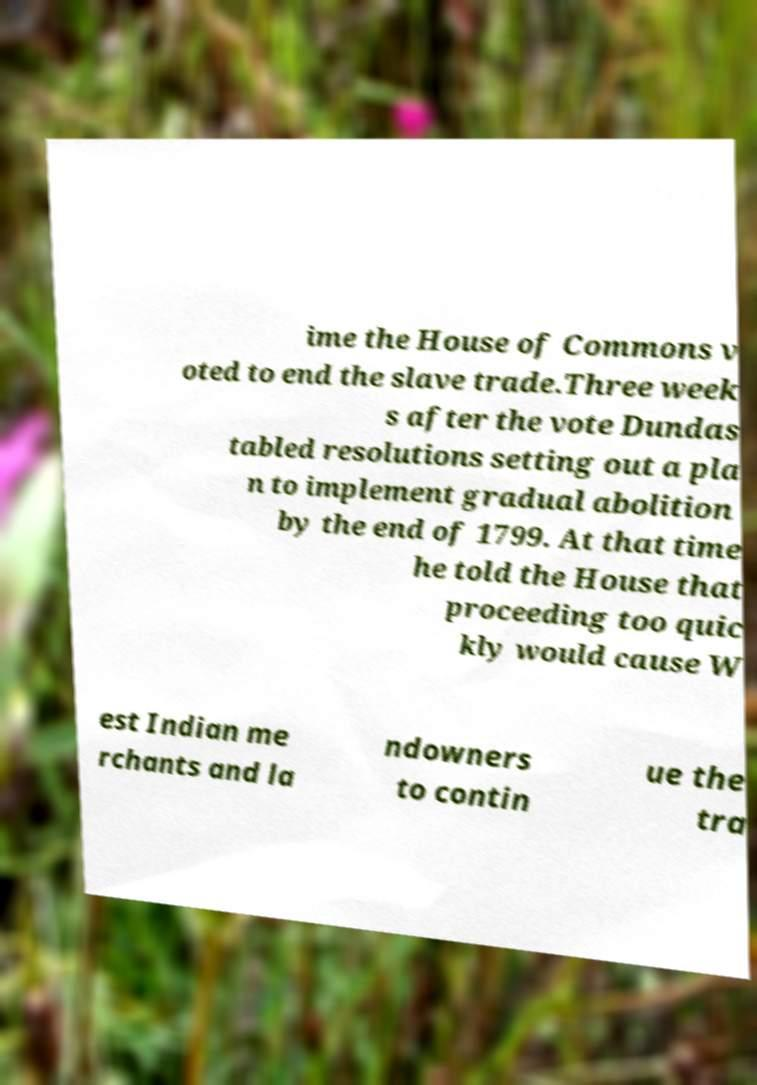For documentation purposes, I need the text within this image transcribed. Could you provide that? ime the House of Commons v oted to end the slave trade.Three week s after the vote Dundas tabled resolutions setting out a pla n to implement gradual abolition by the end of 1799. At that time he told the House that proceeding too quic kly would cause W est Indian me rchants and la ndowners to contin ue the tra 